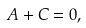Convert formula to latex. <formula><loc_0><loc_0><loc_500><loc_500>A + C = 0 ,</formula> 